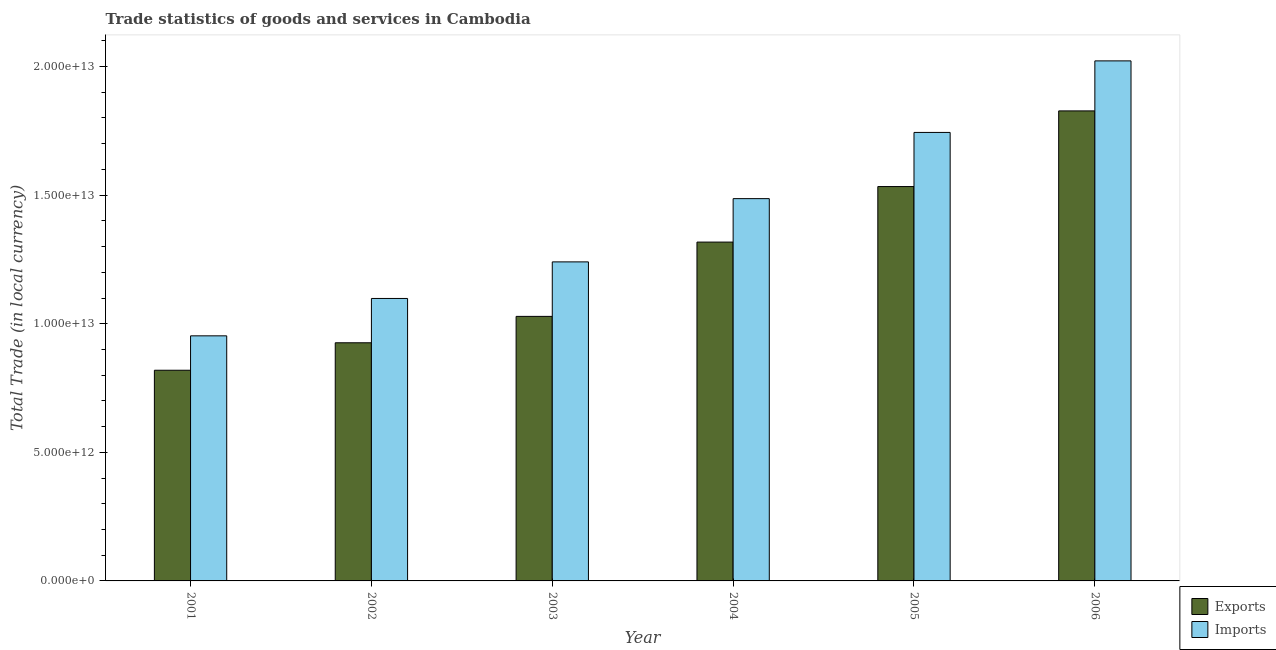Are the number of bars per tick equal to the number of legend labels?
Provide a short and direct response. Yes. Are the number of bars on each tick of the X-axis equal?
Your response must be concise. Yes. How many bars are there on the 5th tick from the left?
Keep it short and to the point. 2. What is the label of the 4th group of bars from the left?
Offer a terse response. 2004. In how many cases, is the number of bars for a given year not equal to the number of legend labels?
Provide a short and direct response. 0. What is the imports of goods and services in 2001?
Your response must be concise. 9.53e+12. Across all years, what is the maximum export of goods and services?
Keep it short and to the point. 1.83e+13. Across all years, what is the minimum imports of goods and services?
Your answer should be compact. 9.53e+12. In which year was the imports of goods and services minimum?
Keep it short and to the point. 2001. What is the total export of goods and services in the graph?
Your answer should be very brief. 7.45e+13. What is the difference between the export of goods and services in 2003 and that in 2005?
Offer a very short reply. -5.05e+12. What is the difference between the imports of goods and services in 2002 and the export of goods and services in 2003?
Your response must be concise. -1.42e+12. What is the average export of goods and services per year?
Offer a terse response. 1.24e+13. In how many years, is the imports of goods and services greater than 7000000000000 LCU?
Give a very brief answer. 6. What is the ratio of the export of goods and services in 2001 to that in 2003?
Provide a short and direct response. 0.8. What is the difference between the highest and the second highest imports of goods and services?
Provide a succinct answer. 2.78e+12. What is the difference between the highest and the lowest imports of goods and services?
Your answer should be very brief. 1.07e+13. Is the sum of the export of goods and services in 2004 and 2006 greater than the maximum imports of goods and services across all years?
Make the answer very short. Yes. What does the 1st bar from the left in 2001 represents?
Keep it short and to the point. Exports. What does the 2nd bar from the right in 2004 represents?
Provide a succinct answer. Exports. How many bars are there?
Provide a succinct answer. 12. How many years are there in the graph?
Offer a very short reply. 6. What is the difference between two consecutive major ticks on the Y-axis?
Keep it short and to the point. 5.00e+12. Are the values on the major ticks of Y-axis written in scientific E-notation?
Your answer should be very brief. Yes. Does the graph contain grids?
Your answer should be compact. No. What is the title of the graph?
Make the answer very short. Trade statistics of goods and services in Cambodia. What is the label or title of the Y-axis?
Your answer should be very brief. Total Trade (in local currency). What is the Total Trade (in local currency) of Exports in 2001?
Your answer should be very brief. 8.19e+12. What is the Total Trade (in local currency) in Imports in 2001?
Your answer should be very brief. 9.53e+12. What is the Total Trade (in local currency) of Exports in 2002?
Ensure brevity in your answer.  9.26e+12. What is the Total Trade (in local currency) of Imports in 2002?
Provide a succinct answer. 1.10e+13. What is the Total Trade (in local currency) in Exports in 2003?
Your answer should be compact. 1.03e+13. What is the Total Trade (in local currency) in Imports in 2003?
Provide a short and direct response. 1.24e+13. What is the Total Trade (in local currency) of Exports in 2004?
Keep it short and to the point. 1.32e+13. What is the Total Trade (in local currency) in Imports in 2004?
Your answer should be compact. 1.49e+13. What is the Total Trade (in local currency) in Exports in 2005?
Your answer should be very brief. 1.53e+13. What is the Total Trade (in local currency) in Imports in 2005?
Provide a short and direct response. 1.74e+13. What is the Total Trade (in local currency) in Exports in 2006?
Keep it short and to the point. 1.83e+13. What is the Total Trade (in local currency) in Imports in 2006?
Provide a short and direct response. 2.02e+13. Across all years, what is the maximum Total Trade (in local currency) of Exports?
Your answer should be very brief. 1.83e+13. Across all years, what is the maximum Total Trade (in local currency) of Imports?
Make the answer very short. 2.02e+13. Across all years, what is the minimum Total Trade (in local currency) of Exports?
Offer a very short reply. 8.19e+12. Across all years, what is the minimum Total Trade (in local currency) of Imports?
Your response must be concise. 9.53e+12. What is the total Total Trade (in local currency) of Exports in the graph?
Provide a short and direct response. 7.45e+13. What is the total Total Trade (in local currency) of Imports in the graph?
Offer a very short reply. 8.54e+13. What is the difference between the Total Trade (in local currency) in Exports in 2001 and that in 2002?
Ensure brevity in your answer.  -1.07e+12. What is the difference between the Total Trade (in local currency) of Imports in 2001 and that in 2002?
Provide a succinct answer. -1.45e+12. What is the difference between the Total Trade (in local currency) of Exports in 2001 and that in 2003?
Your response must be concise. -2.09e+12. What is the difference between the Total Trade (in local currency) in Imports in 2001 and that in 2003?
Give a very brief answer. -2.88e+12. What is the difference between the Total Trade (in local currency) in Exports in 2001 and that in 2004?
Your response must be concise. -4.98e+12. What is the difference between the Total Trade (in local currency) of Imports in 2001 and that in 2004?
Offer a terse response. -5.33e+12. What is the difference between the Total Trade (in local currency) in Exports in 2001 and that in 2005?
Ensure brevity in your answer.  -7.14e+12. What is the difference between the Total Trade (in local currency) in Imports in 2001 and that in 2005?
Provide a short and direct response. -7.91e+12. What is the difference between the Total Trade (in local currency) in Exports in 2001 and that in 2006?
Your answer should be very brief. -1.01e+13. What is the difference between the Total Trade (in local currency) in Imports in 2001 and that in 2006?
Offer a terse response. -1.07e+13. What is the difference between the Total Trade (in local currency) of Exports in 2002 and that in 2003?
Offer a very short reply. -1.03e+12. What is the difference between the Total Trade (in local currency) in Imports in 2002 and that in 2003?
Your response must be concise. -1.42e+12. What is the difference between the Total Trade (in local currency) of Exports in 2002 and that in 2004?
Offer a terse response. -3.91e+12. What is the difference between the Total Trade (in local currency) of Imports in 2002 and that in 2004?
Give a very brief answer. -3.88e+12. What is the difference between the Total Trade (in local currency) in Exports in 2002 and that in 2005?
Ensure brevity in your answer.  -6.07e+12. What is the difference between the Total Trade (in local currency) of Imports in 2002 and that in 2005?
Your answer should be very brief. -6.46e+12. What is the difference between the Total Trade (in local currency) of Exports in 2002 and that in 2006?
Your answer should be compact. -9.02e+12. What is the difference between the Total Trade (in local currency) in Imports in 2002 and that in 2006?
Ensure brevity in your answer.  -9.24e+12. What is the difference between the Total Trade (in local currency) of Exports in 2003 and that in 2004?
Offer a terse response. -2.89e+12. What is the difference between the Total Trade (in local currency) in Imports in 2003 and that in 2004?
Provide a succinct answer. -2.46e+12. What is the difference between the Total Trade (in local currency) of Exports in 2003 and that in 2005?
Ensure brevity in your answer.  -5.05e+12. What is the difference between the Total Trade (in local currency) of Imports in 2003 and that in 2005?
Your answer should be compact. -5.03e+12. What is the difference between the Total Trade (in local currency) in Exports in 2003 and that in 2006?
Your answer should be very brief. -7.99e+12. What is the difference between the Total Trade (in local currency) of Imports in 2003 and that in 2006?
Provide a succinct answer. -7.82e+12. What is the difference between the Total Trade (in local currency) of Exports in 2004 and that in 2005?
Offer a terse response. -2.16e+12. What is the difference between the Total Trade (in local currency) of Imports in 2004 and that in 2005?
Offer a very short reply. -2.57e+12. What is the difference between the Total Trade (in local currency) of Exports in 2004 and that in 2006?
Offer a terse response. -5.10e+12. What is the difference between the Total Trade (in local currency) of Imports in 2004 and that in 2006?
Keep it short and to the point. -5.36e+12. What is the difference between the Total Trade (in local currency) in Exports in 2005 and that in 2006?
Give a very brief answer. -2.94e+12. What is the difference between the Total Trade (in local currency) in Imports in 2005 and that in 2006?
Ensure brevity in your answer.  -2.78e+12. What is the difference between the Total Trade (in local currency) of Exports in 2001 and the Total Trade (in local currency) of Imports in 2002?
Keep it short and to the point. -2.79e+12. What is the difference between the Total Trade (in local currency) in Exports in 2001 and the Total Trade (in local currency) in Imports in 2003?
Make the answer very short. -4.21e+12. What is the difference between the Total Trade (in local currency) in Exports in 2001 and the Total Trade (in local currency) in Imports in 2004?
Make the answer very short. -6.67e+12. What is the difference between the Total Trade (in local currency) in Exports in 2001 and the Total Trade (in local currency) in Imports in 2005?
Your answer should be very brief. -9.25e+12. What is the difference between the Total Trade (in local currency) in Exports in 2001 and the Total Trade (in local currency) in Imports in 2006?
Your answer should be very brief. -1.20e+13. What is the difference between the Total Trade (in local currency) of Exports in 2002 and the Total Trade (in local currency) of Imports in 2003?
Offer a terse response. -3.15e+12. What is the difference between the Total Trade (in local currency) of Exports in 2002 and the Total Trade (in local currency) of Imports in 2004?
Provide a succinct answer. -5.60e+12. What is the difference between the Total Trade (in local currency) of Exports in 2002 and the Total Trade (in local currency) of Imports in 2005?
Provide a succinct answer. -8.18e+12. What is the difference between the Total Trade (in local currency) of Exports in 2002 and the Total Trade (in local currency) of Imports in 2006?
Give a very brief answer. -1.10e+13. What is the difference between the Total Trade (in local currency) of Exports in 2003 and the Total Trade (in local currency) of Imports in 2004?
Give a very brief answer. -4.58e+12. What is the difference between the Total Trade (in local currency) in Exports in 2003 and the Total Trade (in local currency) in Imports in 2005?
Offer a terse response. -7.15e+12. What is the difference between the Total Trade (in local currency) of Exports in 2003 and the Total Trade (in local currency) of Imports in 2006?
Your answer should be very brief. -9.93e+12. What is the difference between the Total Trade (in local currency) of Exports in 2004 and the Total Trade (in local currency) of Imports in 2005?
Your answer should be compact. -4.26e+12. What is the difference between the Total Trade (in local currency) of Exports in 2004 and the Total Trade (in local currency) of Imports in 2006?
Your answer should be compact. -7.05e+12. What is the difference between the Total Trade (in local currency) of Exports in 2005 and the Total Trade (in local currency) of Imports in 2006?
Keep it short and to the point. -4.89e+12. What is the average Total Trade (in local currency) in Exports per year?
Offer a very short reply. 1.24e+13. What is the average Total Trade (in local currency) of Imports per year?
Give a very brief answer. 1.42e+13. In the year 2001, what is the difference between the Total Trade (in local currency) of Exports and Total Trade (in local currency) of Imports?
Provide a short and direct response. -1.34e+12. In the year 2002, what is the difference between the Total Trade (in local currency) of Exports and Total Trade (in local currency) of Imports?
Provide a succinct answer. -1.72e+12. In the year 2003, what is the difference between the Total Trade (in local currency) in Exports and Total Trade (in local currency) in Imports?
Provide a succinct answer. -2.12e+12. In the year 2004, what is the difference between the Total Trade (in local currency) of Exports and Total Trade (in local currency) of Imports?
Provide a succinct answer. -1.69e+12. In the year 2005, what is the difference between the Total Trade (in local currency) in Exports and Total Trade (in local currency) in Imports?
Your answer should be very brief. -2.10e+12. In the year 2006, what is the difference between the Total Trade (in local currency) of Exports and Total Trade (in local currency) of Imports?
Offer a very short reply. -1.94e+12. What is the ratio of the Total Trade (in local currency) in Exports in 2001 to that in 2002?
Your answer should be very brief. 0.88. What is the ratio of the Total Trade (in local currency) in Imports in 2001 to that in 2002?
Provide a short and direct response. 0.87. What is the ratio of the Total Trade (in local currency) in Exports in 2001 to that in 2003?
Give a very brief answer. 0.8. What is the ratio of the Total Trade (in local currency) of Imports in 2001 to that in 2003?
Provide a succinct answer. 0.77. What is the ratio of the Total Trade (in local currency) of Exports in 2001 to that in 2004?
Keep it short and to the point. 0.62. What is the ratio of the Total Trade (in local currency) in Imports in 2001 to that in 2004?
Provide a succinct answer. 0.64. What is the ratio of the Total Trade (in local currency) of Exports in 2001 to that in 2005?
Your response must be concise. 0.53. What is the ratio of the Total Trade (in local currency) of Imports in 2001 to that in 2005?
Ensure brevity in your answer.  0.55. What is the ratio of the Total Trade (in local currency) in Exports in 2001 to that in 2006?
Offer a terse response. 0.45. What is the ratio of the Total Trade (in local currency) of Imports in 2001 to that in 2006?
Give a very brief answer. 0.47. What is the ratio of the Total Trade (in local currency) in Exports in 2002 to that in 2003?
Offer a terse response. 0.9. What is the ratio of the Total Trade (in local currency) in Imports in 2002 to that in 2003?
Make the answer very short. 0.89. What is the ratio of the Total Trade (in local currency) in Exports in 2002 to that in 2004?
Your answer should be compact. 0.7. What is the ratio of the Total Trade (in local currency) in Imports in 2002 to that in 2004?
Provide a succinct answer. 0.74. What is the ratio of the Total Trade (in local currency) in Exports in 2002 to that in 2005?
Your response must be concise. 0.6. What is the ratio of the Total Trade (in local currency) in Imports in 2002 to that in 2005?
Your answer should be compact. 0.63. What is the ratio of the Total Trade (in local currency) of Exports in 2002 to that in 2006?
Your answer should be very brief. 0.51. What is the ratio of the Total Trade (in local currency) in Imports in 2002 to that in 2006?
Ensure brevity in your answer.  0.54. What is the ratio of the Total Trade (in local currency) in Exports in 2003 to that in 2004?
Your response must be concise. 0.78. What is the ratio of the Total Trade (in local currency) in Imports in 2003 to that in 2004?
Provide a succinct answer. 0.83. What is the ratio of the Total Trade (in local currency) of Exports in 2003 to that in 2005?
Your answer should be compact. 0.67. What is the ratio of the Total Trade (in local currency) in Imports in 2003 to that in 2005?
Provide a succinct answer. 0.71. What is the ratio of the Total Trade (in local currency) of Exports in 2003 to that in 2006?
Your response must be concise. 0.56. What is the ratio of the Total Trade (in local currency) in Imports in 2003 to that in 2006?
Ensure brevity in your answer.  0.61. What is the ratio of the Total Trade (in local currency) in Exports in 2004 to that in 2005?
Ensure brevity in your answer.  0.86. What is the ratio of the Total Trade (in local currency) of Imports in 2004 to that in 2005?
Ensure brevity in your answer.  0.85. What is the ratio of the Total Trade (in local currency) of Exports in 2004 to that in 2006?
Give a very brief answer. 0.72. What is the ratio of the Total Trade (in local currency) in Imports in 2004 to that in 2006?
Make the answer very short. 0.74. What is the ratio of the Total Trade (in local currency) of Exports in 2005 to that in 2006?
Provide a short and direct response. 0.84. What is the ratio of the Total Trade (in local currency) of Imports in 2005 to that in 2006?
Your response must be concise. 0.86. What is the difference between the highest and the second highest Total Trade (in local currency) in Exports?
Make the answer very short. 2.94e+12. What is the difference between the highest and the second highest Total Trade (in local currency) of Imports?
Ensure brevity in your answer.  2.78e+12. What is the difference between the highest and the lowest Total Trade (in local currency) of Exports?
Offer a terse response. 1.01e+13. What is the difference between the highest and the lowest Total Trade (in local currency) of Imports?
Provide a succinct answer. 1.07e+13. 